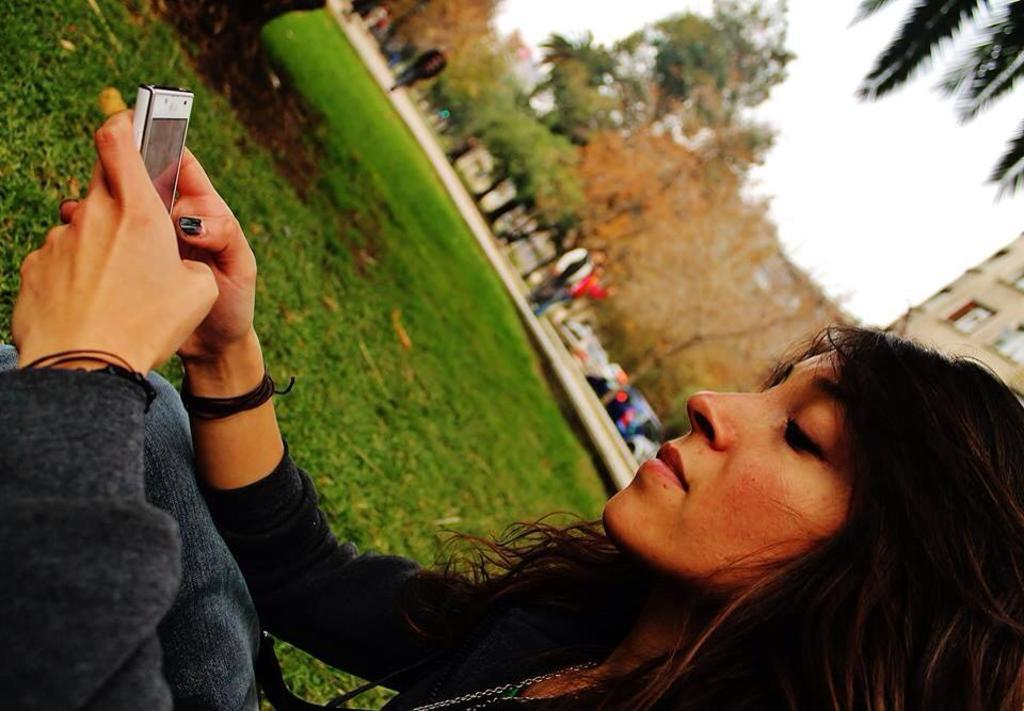What is the main subject in the foreground of the picture? There is a woman in the foreground of the picture. What is the woman holding in the picture? The woman is holding a mobile. What type of natural environment is visible in the center of the image? There is grass in the center of the image. What can be seen in the background of the picture? There are trees, people, vehicles, and a building in the background of the picture. What type of linen is draped over the trees in the background? There is no linen draped over the trees in the background; the trees are visible without any fabric covering them. 